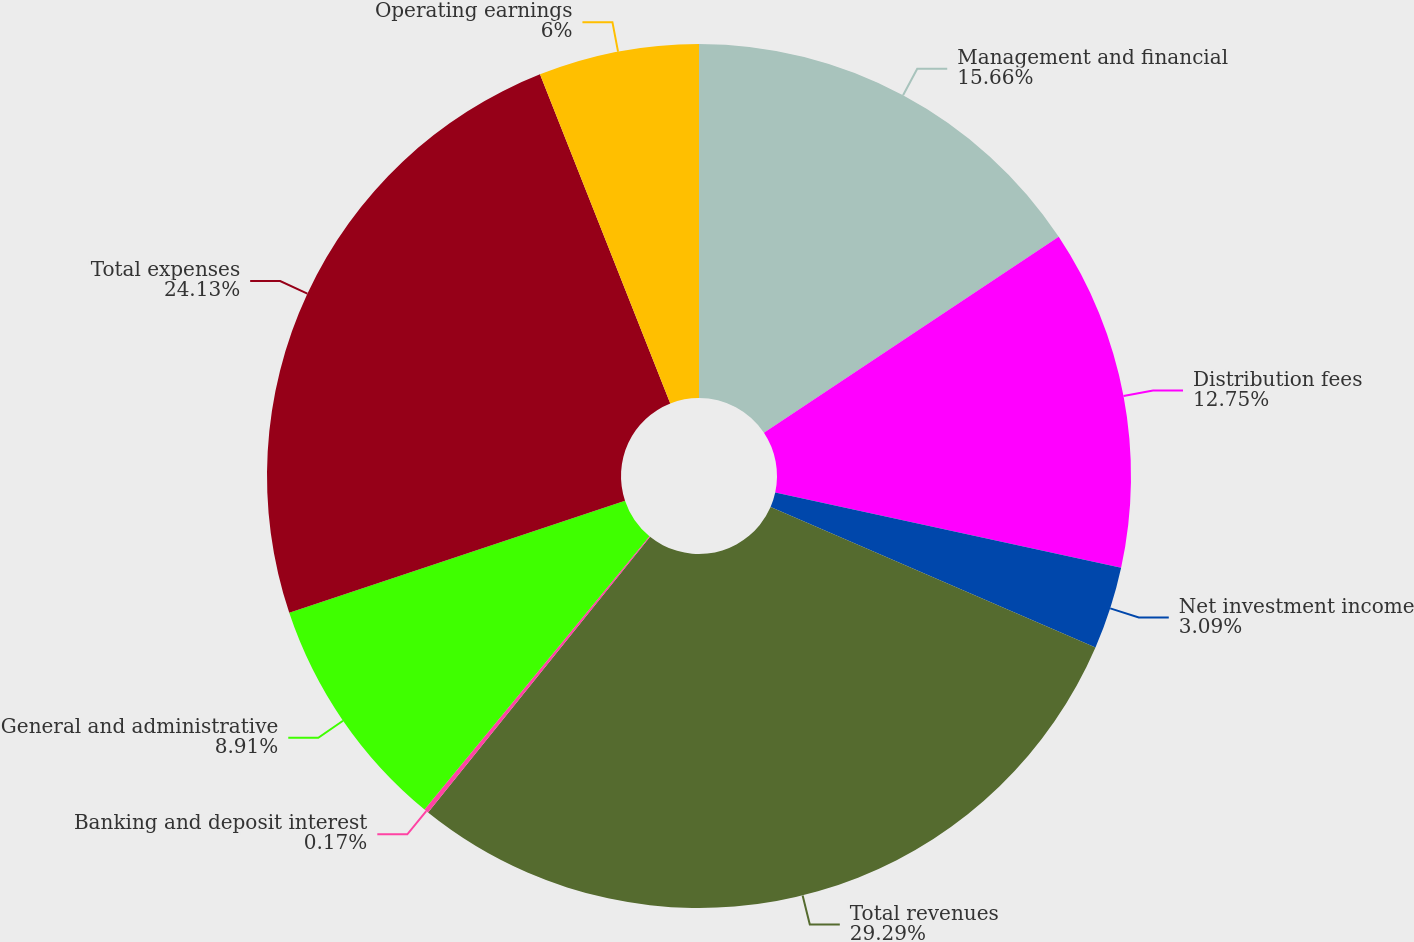Convert chart to OTSL. <chart><loc_0><loc_0><loc_500><loc_500><pie_chart><fcel>Management and financial<fcel>Distribution fees<fcel>Net investment income<fcel>Total revenues<fcel>Banking and deposit interest<fcel>General and administrative<fcel>Total expenses<fcel>Operating earnings<nl><fcel>15.66%<fcel>12.75%<fcel>3.09%<fcel>29.29%<fcel>0.17%<fcel>8.91%<fcel>24.13%<fcel>6.0%<nl></chart> 